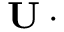Convert formula to latex. <formula><loc_0><loc_0><loc_500><loc_500>U \cdot \partial</formula> 